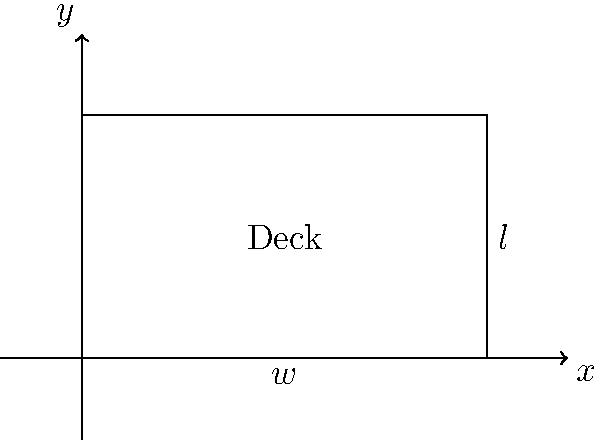As a professional deck builder, you want to optimize the dimensions of a rectangular deck to minimize costs while meeting specific requirements. The cost of decking material is $20 per square foot, and the cost of railing is $25 per linear foot. The deck must have a perimeter of 100 feet and an area of at least 300 square feet. What dimensions (length and width) will result in the minimum total cost for the deck? Let's approach this step-by-step:

1) Define variables:
   Let $l$ = length and $w$ = width of the deck

2) Express constraints:
   Perimeter: $2l + 2w = 100$
   Area: $lw \geq 300$

3) Express the cost function:
   Cost = Area cost + Perimeter cost
   $C = 20lw + 25(2l + 2w)$
   $C = 20lw + 50l + 50w$

4) Express $l$ in terms of $w$ using the perimeter constraint:
   $l = 50 - w$

5) Substitute this into the cost function:
   $C = 20w(50-w) + 50(50-w) + 50w$
   $C = 1000w - 20w^2 + 2500 - 50w + 50w$
   $C = -20w^2 + 1000w + 2500$

6) To find the minimum cost, differentiate $C$ with respect to $w$ and set it to zero:
   $\frac{dC}{dw} = -40w + 1000 = 0$
   $40w = 1000$
   $w = 25$

7) Calculate $l$:
   $l = 50 - w = 50 - 25 = 25$

8) Check if this satisfies the area constraint:
   Area = $25 * 25 = 625$ sq ft, which is $\geq 300$ sq ft

Therefore, the optimal dimensions are 25 feet by 25 feet.
Answer: 25 ft × 25 ft 